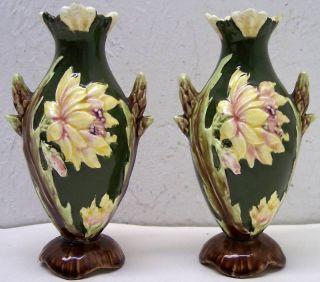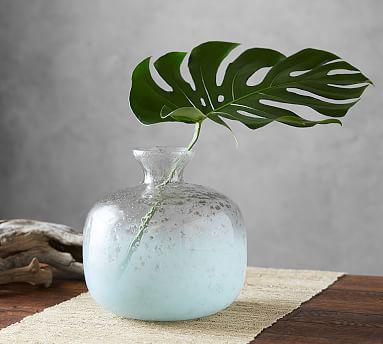The first image is the image on the left, the second image is the image on the right. For the images shown, is this caption "To the right, it appears as though one branch is held within a vase." true? Answer yes or no. Yes. 